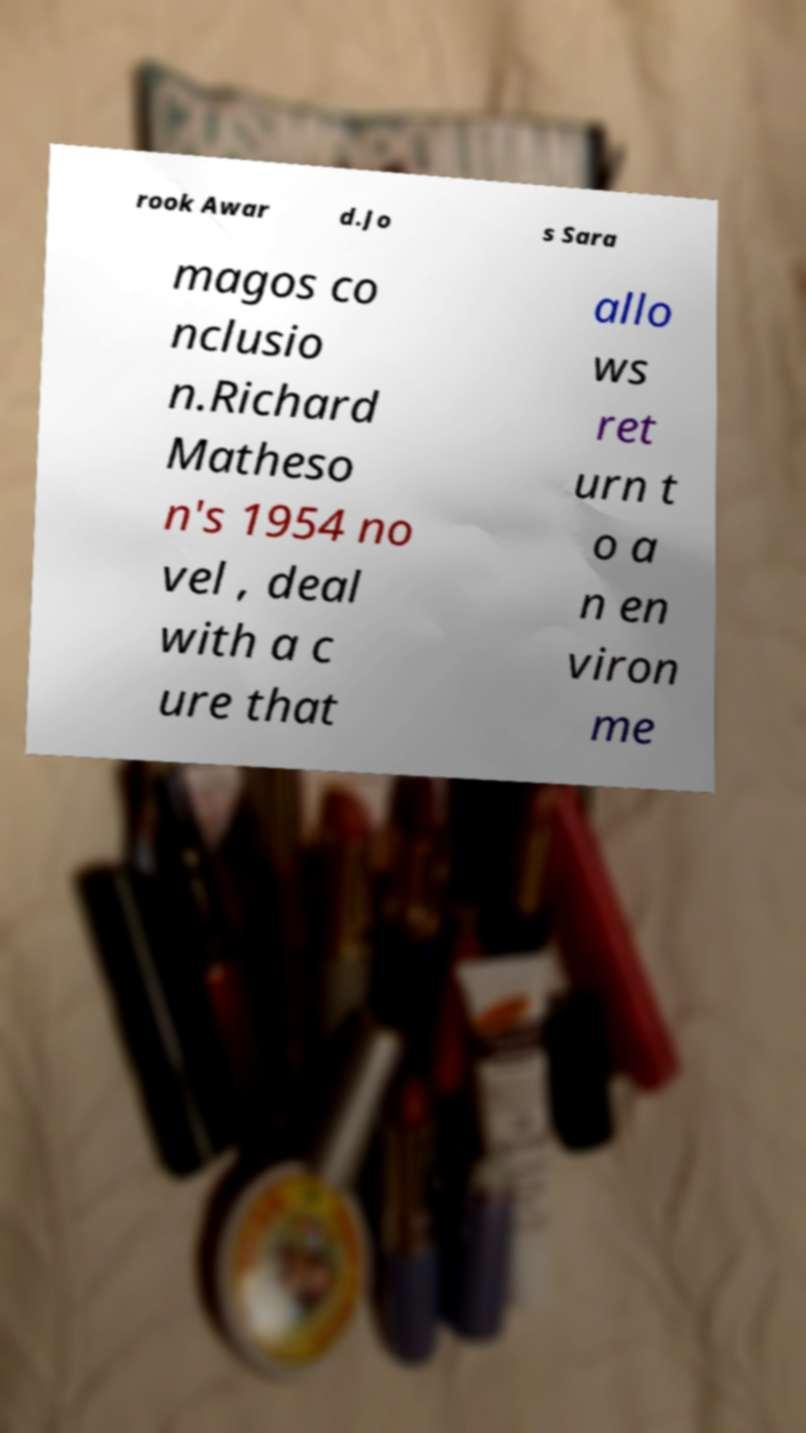What messages or text are displayed in this image? I need them in a readable, typed format. rook Awar d.Jo s Sara magos co nclusio n.Richard Matheso n's 1954 no vel , deal with a c ure that allo ws ret urn t o a n en viron me 